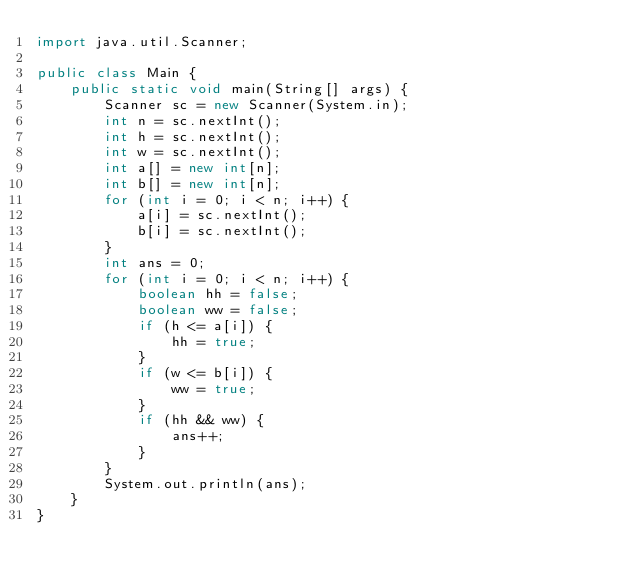<code> <loc_0><loc_0><loc_500><loc_500><_Java_>import java.util.Scanner;

public class Main {
    public static void main(String[] args) {
        Scanner sc = new Scanner(System.in);
        int n = sc.nextInt();
        int h = sc.nextInt();
        int w = sc.nextInt();
        int a[] = new int[n];
        int b[] = new int[n];
        for (int i = 0; i < n; i++) {
            a[i] = sc.nextInt();
            b[i] = sc.nextInt();
        }
        int ans = 0;
        for (int i = 0; i < n; i++) {
            boolean hh = false;
            boolean ww = false;
            if (h <= a[i]) {
                hh = true;
            }
            if (w <= b[i]) {
                ww = true;
            }
            if (hh && ww) {
                ans++;
            }
        }
        System.out.println(ans);
    }
}</code> 